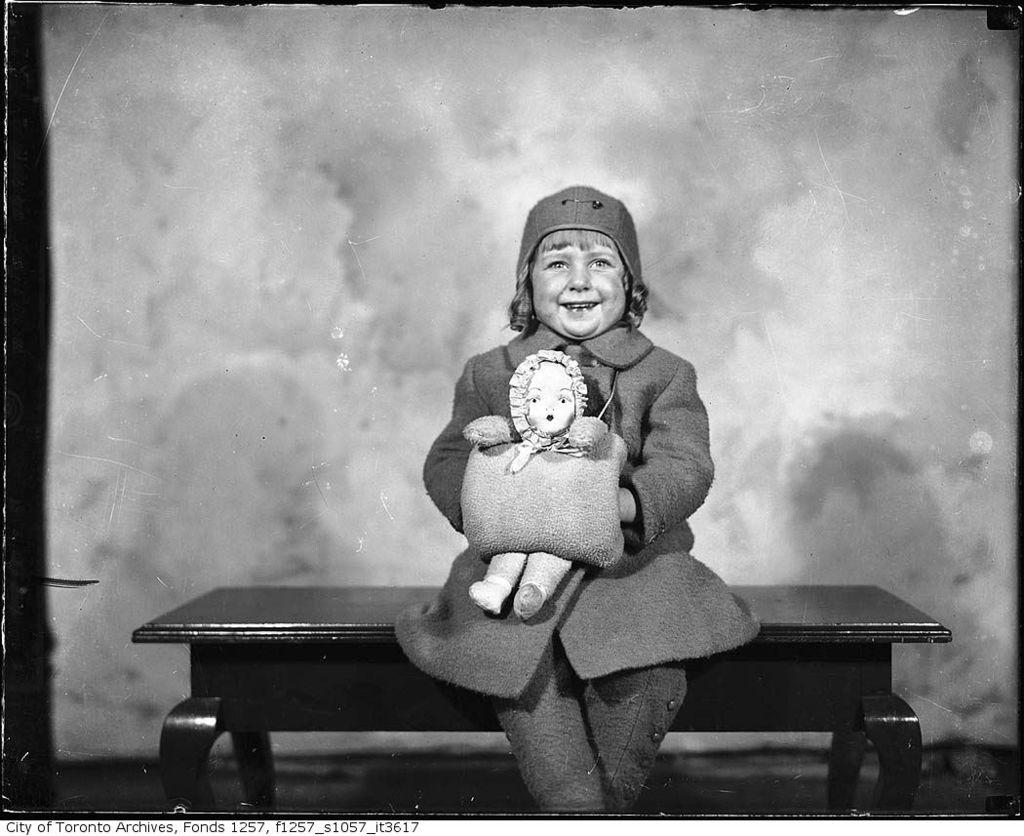What is the main subject of the image? There is a child in the image. What is the child doing in the image? The child is sitting on a table. What is the child wearing in the image? The child is wearing a jacket and a cap. What is the child's facial expression in the image? The child is smiling. What is the child holding in the image? The child is holding a toy in her hand. What type of flame can be seen near the child in the image? There is no flame present in the image; it features a child sitting on a table, wearing a jacket and cap, smiling, and holding a toy. 